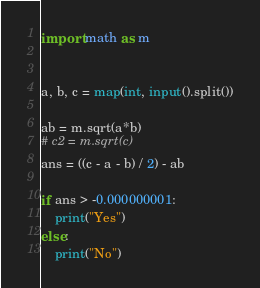<code> <loc_0><loc_0><loc_500><loc_500><_Python_>import math as m


a, b, c = map(int, input().split())

ab = m.sqrt(a*b)
# c2 = m.sqrt(c)
ans = ((c - a - b) / 2) - ab

if ans > -0.000000001:
    print("Yes")
else:
    print("No")
</code> 